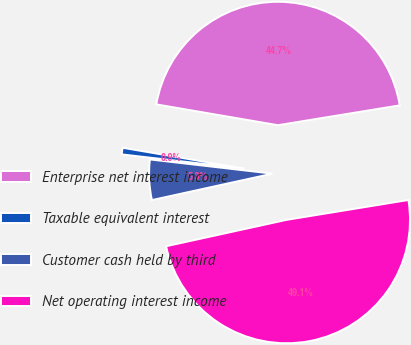Convert chart to OTSL. <chart><loc_0><loc_0><loc_500><loc_500><pie_chart><fcel>Enterprise net interest income<fcel>Taxable equivalent interest<fcel>Customer cash held by third<fcel>Net operating interest income<nl><fcel>44.73%<fcel>0.86%<fcel>5.27%<fcel>49.14%<nl></chart> 